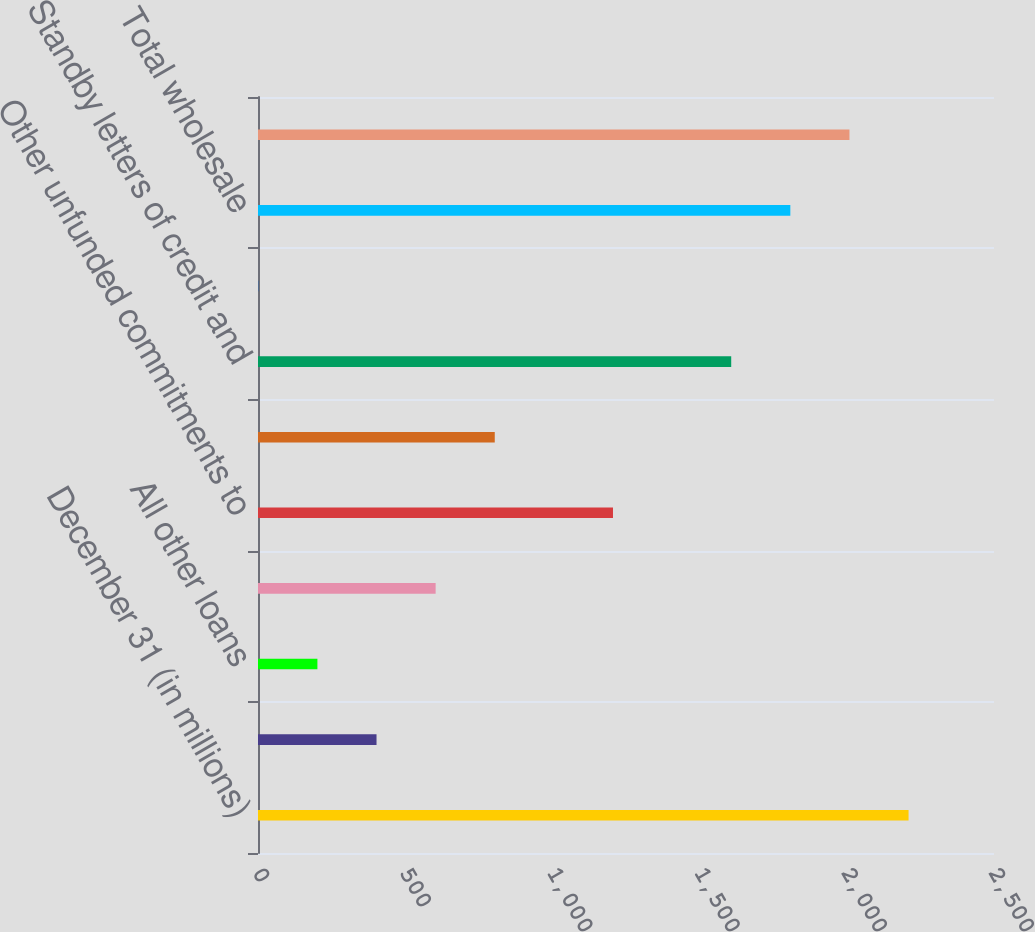Convert chart to OTSL. <chart><loc_0><loc_0><loc_500><loc_500><bar_chart><fcel>December 31 (in millions)<fcel>Auto loans<fcel>All other loans<fcel>Total consumer<fcel>Other unfunded commitments to<fcel>Asset purchase agreements<fcel>Standby letters of credit and<fcel>Other letters of credit (a)(b)<fcel>Total wholesale<fcel>Total lending-related<nl><fcel>2209.8<fcel>402.6<fcel>201.8<fcel>603.4<fcel>1205.8<fcel>804.2<fcel>1607.4<fcel>1<fcel>1808.2<fcel>2009<nl></chart> 